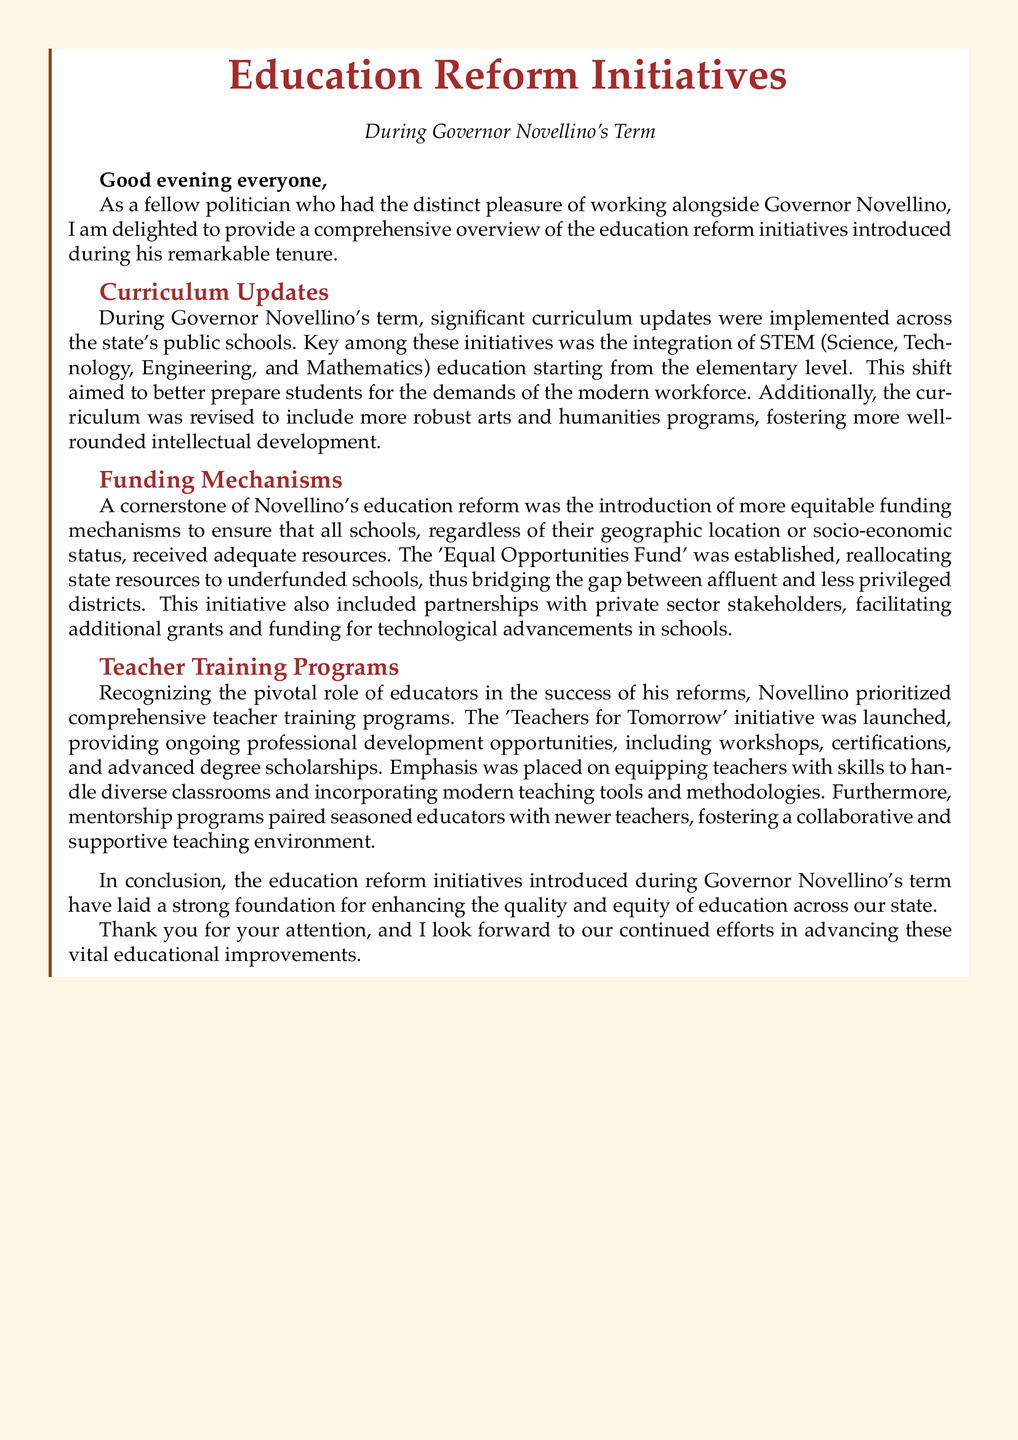What key educational area was integrated into the curriculum? The document states that STEM education was integrated into the curriculum starting from the elementary level.
Answer: STEM education What is the name of the funding initiative introduced by Novellino? The document mentions that the 'Equal Opportunities Fund' was established to aid underfunded schools.
Answer: Equal Opportunities Fund What was a major objective of the teacher training programs? The document highlights that the training programs aimed to equip teachers with skills to handle diverse classrooms.
Answer: Diverse classrooms What type of arts programs were included in the curriculum updates? The document indicates that more robust arts and humanities programs were included in the curriculum updates.
Answer: Arts and humanities How did Novellino's reforms aim to address educational inequity? The document explains that equitable funding mechanisms were introduced to ensure all schools received adequate resources, thus bridging the gap between affluent and less privileged districts.
Answer: Equitable funding mechanisms What initiative provided professional development for teachers? The document states that the 'Teachers for Tomorrow' initiative was launched to provide ongoing professional development opportunities.
Answer: Teachers for Tomorrow Which sector was involved in partnerships for funding? The document mentions that partnerships with private sector stakeholders were facilitated for additional grants and funding.
Answer: Private sector What foundational goal do these education reform initiatives aim to achieve? The document concludes that these initiatives aim to enhance the quality and equity of education across the state.
Answer: Quality and equity of education 